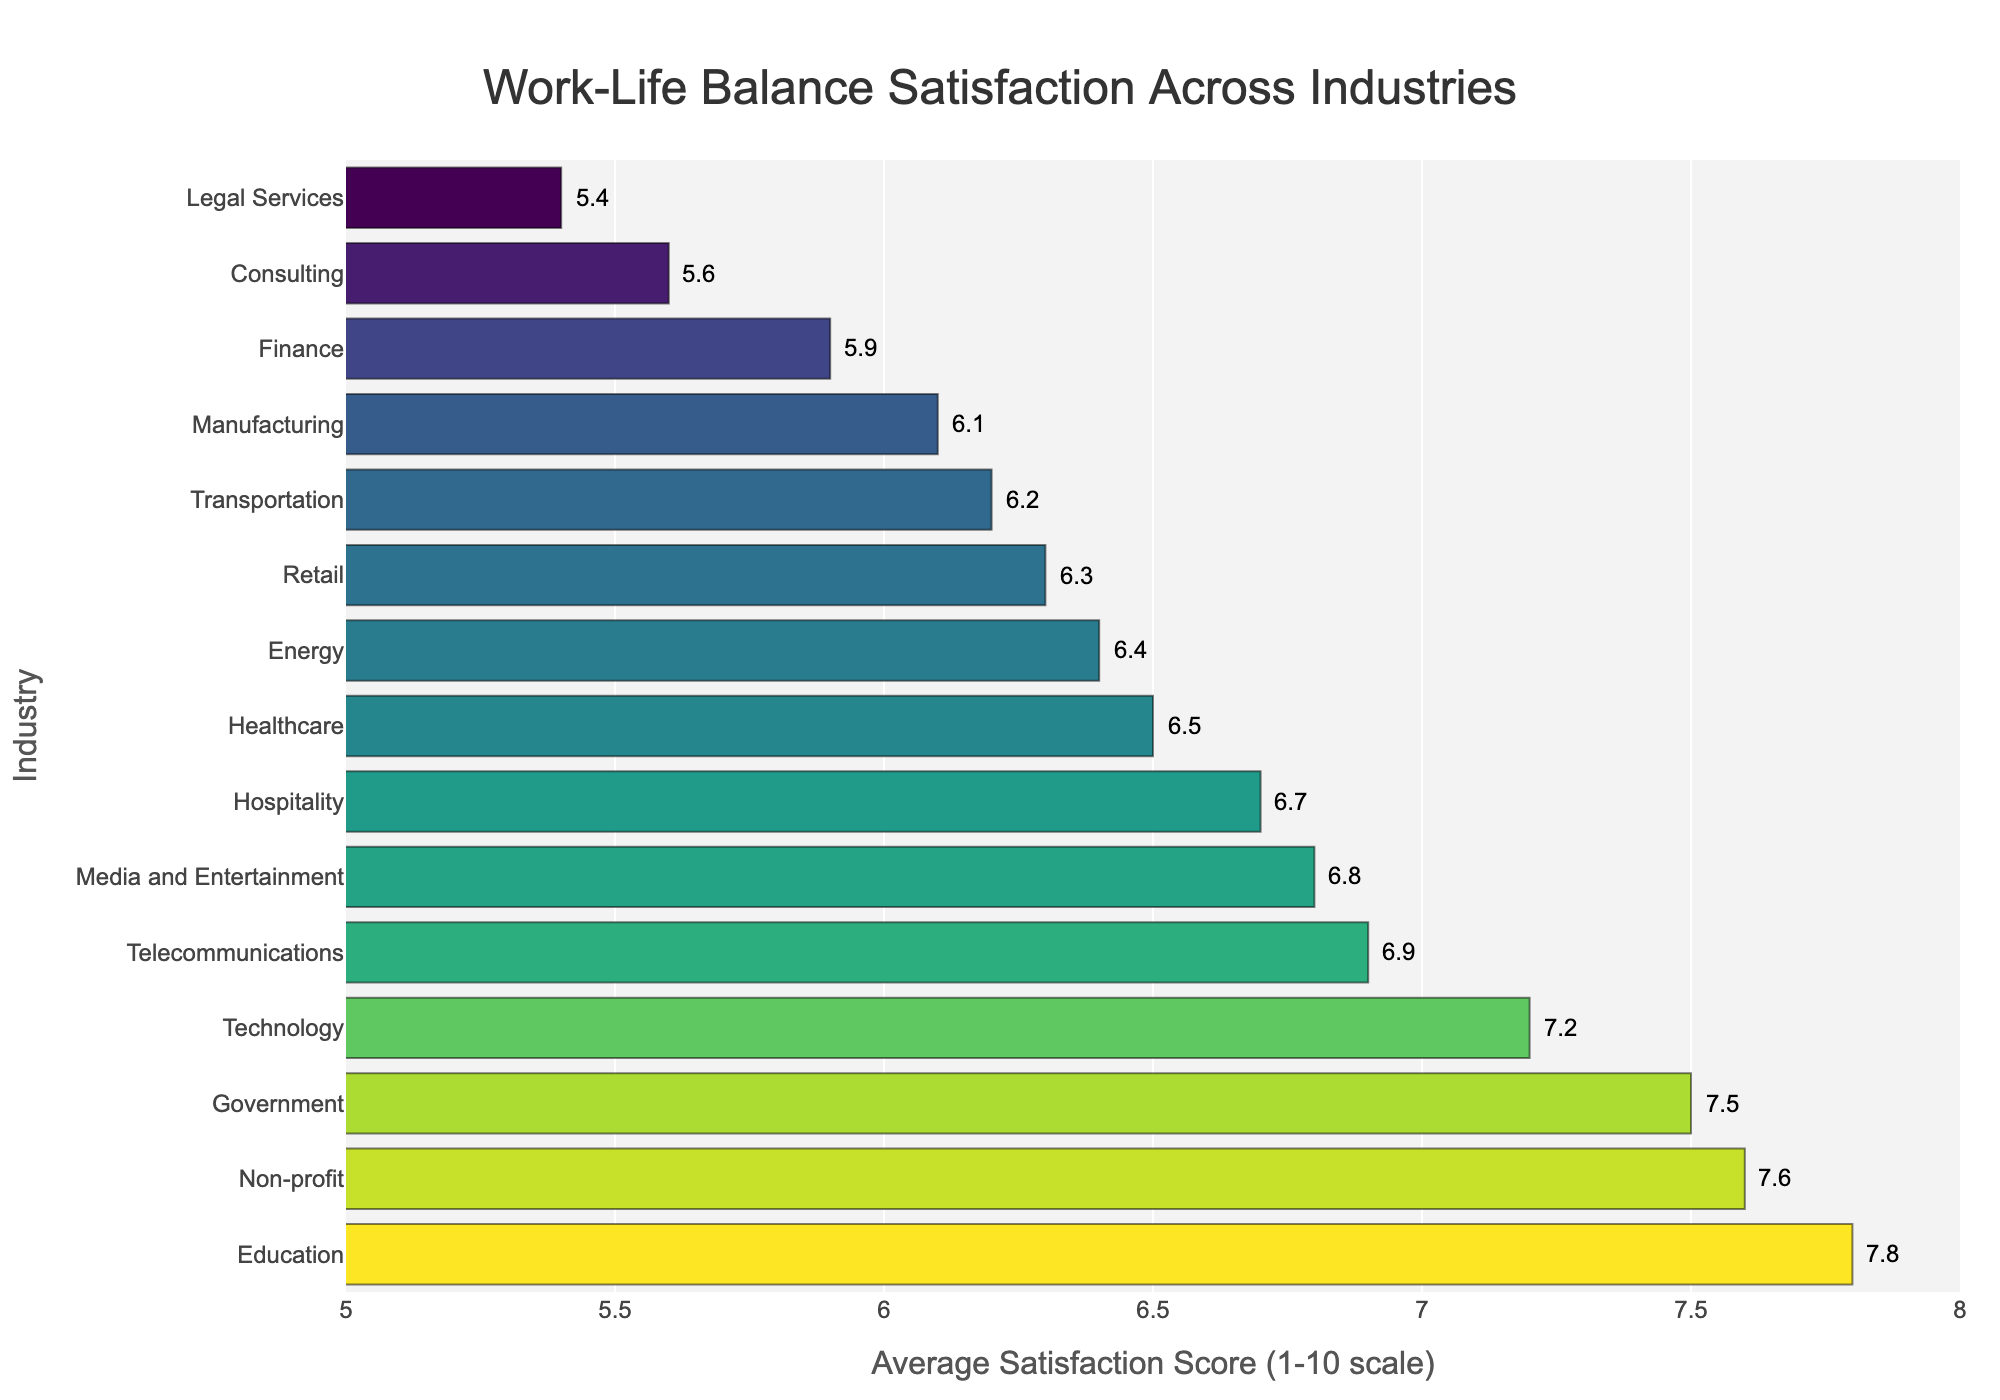Which industry has the highest work-life balance satisfaction score? By examining the bar chart, we identify the bar with the maximum length. Education stands out with an average satisfaction score of 7.8, making it the highest.
Answer: Education Which two industries have the lowest work-life balance satisfaction scores? To find the two industries with the lowest scores, we observe the shortest bars in the chart. These belong to Legal Services and Consulting, with scores of 5.4 and 5.6, respectively.
Answer: Legal Services and Consulting What's the difference in work-life balance satisfaction between Healthcare and Finance? Healthcare has a score of 6.5 while Finance has 5.9. The difference is calculated as 6.5 - 5.9 = 0.6.
Answer: 0.6 How many industries have a work-life balance satisfaction score of 7.0 or higher? We count the number of bars whose lengths correspond to scores of 7.0 or greater. These industries are Technology (7.2), Education (7.8), Government (7.5), and Non-profit (7.6). Thus, there are four such industries.
Answer: 4 Which industry has a work-life balance satisfaction score closest to the average of Retail and Energy? The average score for Retail and Energy is calculated by averaging their scores: (6.3 + 6.4) / 2 = 6.35. Comparing this to the available data, the industry with the closest score is Transportation with 6.2.
Answer: Transportation What is the difference between the highest and lowest work-life balance satisfaction scores? The highest score is in Education (7.8) and the lowest is in Legal Services (5.4). The difference is 7.8 - 5.4 = 2.4.
Answer: 2.4 Which industry has a higher work-life balance satisfaction score, Media and Entertainment or Telecommunications? Checking the bar lengths, Media and Entertainment scores 6.8, while Telecommunications scores 6.9. Therefore, Telecommunications has the higher score.
Answer: Telecommunications Which industries fall within the satisfaction score range of 6.0 to 7.0? Observing the chart, the industries within the 6.0 to 7.0 range include Healthcare (6.5), Retail (6.3), Manufacturing (6.1), Hospitality (6.7), Media and Entertainment (6.8), Telecommunications (6.9), Energy (6.4), and Transportation (6.2).
Answer: Healthcare, Retail, Manufacturing, Hospitality, Media and Entertainment, Telecommunications, Energy, Transportation What is the median work-life balance satisfaction score among the industries? To find the median, first list the scores in ascending order: 5.4, 5.6, 5.9, 6.1, 6.2, 6.3, 6.4, 6.5, 6.7, 6.8, 6.9, 7.2, 7.5, 7.6, 7.8. The middle value (8th in a list of 15) is 6.5.
Answer: 6.5 